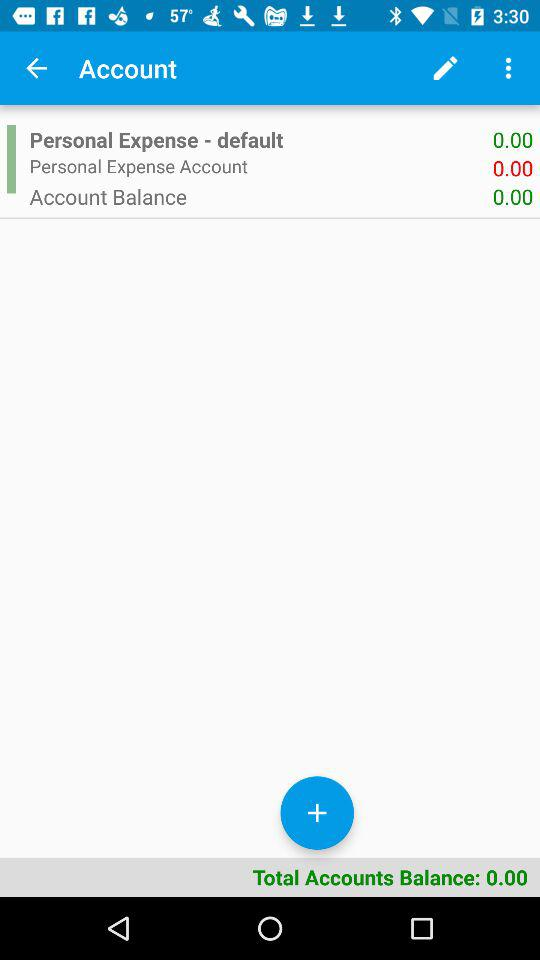What is the total account balance? The total account balance is 0.00. 